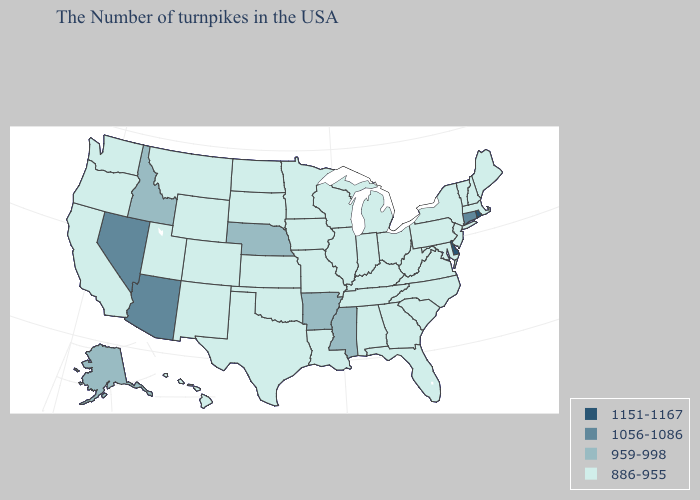Name the states that have a value in the range 1151-1167?
Be succinct. Rhode Island, Delaware. Name the states that have a value in the range 1151-1167?
Short answer required. Rhode Island, Delaware. What is the value of Iowa?
Short answer required. 886-955. What is the value of Wisconsin?
Keep it brief. 886-955. Does Indiana have the lowest value in the MidWest?
Short answer required. Yes. Does Nebraska have the lowest value in the MidWest?
Answer briefly. No. Name the states that have a value in the range 1151-1167?
Keep it brief. Rhode Island, Delaware. Which states have the lowest value in the West?
Quick response, please. Wyoming, Colorado, New Mexico, Utah, Montana, California, Washington, Oregon, Hawaii. Name the states that have a value in the range 1056-1086?
Concise answer only. Connecticut, Arizona, Nevada. Does the first symbol in the legend represent the smallest category?
Write a very short answer. No. Does Rhode Island have the lowest value in the USA?
Concise answer only. No. Does Nebraska have the highest value in the MidWest?
Keep it brief. Yes. Among the states that border Colorado , does Oklahoma have the highest value?
Write a very short answer. No. What is the lowest value in the MidWest?
Concise answer only. 886-955. Name the states that have a value in the range 1056-1086?
Concise answer only. Connecticut, Arizona, Nevada. 